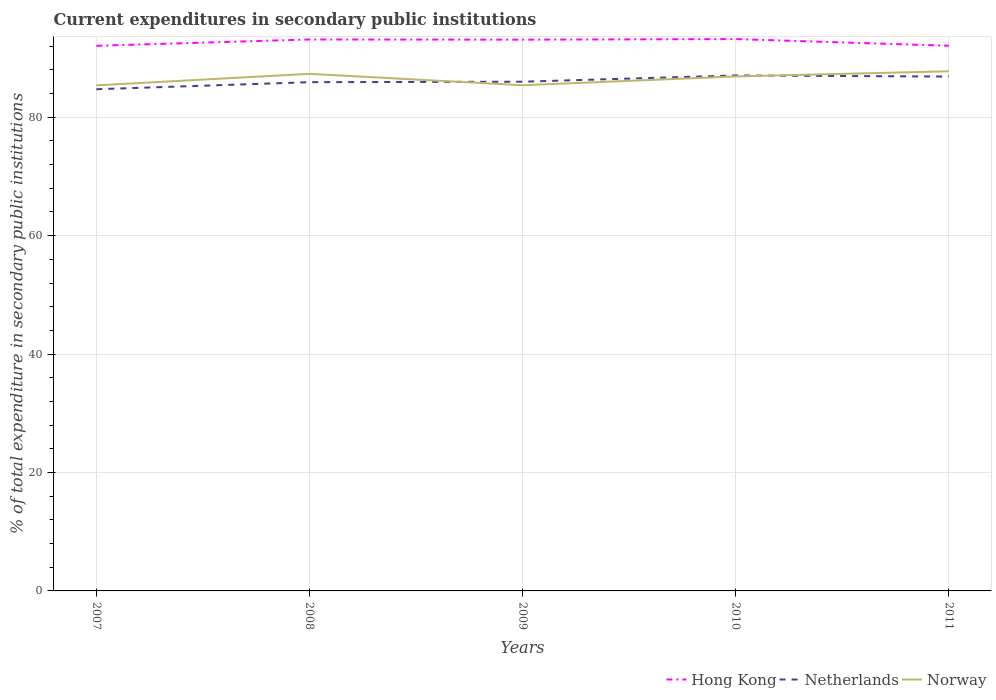Does the line corresponding to Hong Kong intersect with the line corresponding to Norway?
Your response must be concise. No. Is the number of lines equal to the number of legend labels?
Ensure brevity in your answer.  Yes. Across all years, what is the maximum current expenditures in secondary public institutions in Hong Kong?
Make the answer very short. 92.06. What is the total current expenditures in secondary public institutions in Norway in the graph?
Make the answer very short. -1.94. What is the difference between the highest and the second highest current expenditures in secondary public institutions in Netherlands?
Provide a short and direct response. 2.33. Is the current expenditures in secondary public institutions in Hong Kong strictly greater than the current expenditures in secondary public institutions in Norway over the years?
Make the answer very short. No. How many years are there in the graph?
Keep it short and to the point. 5. What is the difference between two consecutive major ticks on the Y-axis?
Give a very brief answer. 20. Are the values on the major ticks of Y-axis written in scientific E-notation?
Keep it short and to the point. No. Does the graph contain any zero values?
Make the answer very short. No. Does the graph contain grids?
Your answer should be very brief. Yes. How many legend labels are there?
Offer a very short reply. 3. What is the title of the graph?
Make the answer very short. Current expenditures in secondary public institutions. What is the label or title of the Y-axis?
Offer a terse response. % of total expenditure in secondary public institutions. What is the % of total expenditure in secondary public institutions of Hong Kong in 2007?
Provide a short and direct response. 92.06. What is the % of total expenditure in secondary public institutions of Netherlands in 2007?
Offer a very short reply. 84.72. What is the % of total expenditure in secondary public institutions in Norway in 2007?
Provide a short and direct response. 85.38. What is the % of total expenditure in secondary public institutions of Hong Kong in 2008?
Your answer should be compact. 93.13. What is the % of total expenditure in secondary public institutions of Netherlands in 2008?
Your answer should be compact. 85.92. What is the % of total expenditure in secondary public institutions in Norway in 2008?
Offer a terse response. 87.32. What is the % of total expenditure in secondary public institutions in Hong Kong in 2009?
Provide a succinct answer. 93.1. What is the % of total expenditure in secondary public institutions in Netherlands in 2009?
Provide a succinct answer. 86. What is the % of total expenditure in secondary public institutions of Norway in 2009?
Make the answer very short. 85.4. What is the % of total expenditure in secondary public institutions of Hong Kong in 2010?
Give a very brief answer. 93.19. What is the % of total expenditure in secondary public institutions in Netherlands in 2010?
Give a very brief answer. 87.05. What is the % of total expenditure in secondary public institutions of Norway in 2010?
Your answer should be compact. 86.89. What is the % of total expenditure in secondary public institutions in Hong Kong in 2011?
Offer a very short reply. 92.07. What is the % of total expenditure in secondary public institutions in Netherlands in 2011?
Ensure brevity in your answer.  86.86. What is the % of total expenditure in secondary public institutions of Norway in 2011?
Your response must be concise. 87.75. Across all years, what is the maximum % of total expenditure in secondary public institutions of Hong Kong?
Ensure brevity in your answer.  93.19. Across all years, what is the maximum % of total expenditure in secondary public institutions in Netherlands?
Keep it short and to the point. 87.05. Across all years, what is the maximum % of total expenditure in secondary public institutions of Norway?
Your answer should be compact. 87.75. Across all years, what is the minimum % of total expenditure in secondary public institutions of Hong Kong?
Keep it short and to the point. 92.06. Across all years, what is the minimum % of total expenditure in secondary public institutions in Netherlands?
Make the answer very short. 84.72. Across all years, what is the minimum % of total expenditure in secondary public institutions in Norway?
Ensure brevity in your answer.  85.38. What is the total % of total expenditure in secondary public institutions of Hong Kong in the graph?
Your response must be concise. 463.55. What is the total % of total expenditure in secondary public institutions in Netherlands in the graph?
Offer a terse response. 430.55. What is the total % of total expenditure in secondary public institutions of Norway in the graph?
Ensure brevity in your answer.  432.74. What is the difference between the % of total expenditure in secondary public institutions of Hong Kong in 2007 and that in 2008?
Your answer should be very brief. -1.07. What is the difference between the % of total expenditure in secondary public institutions of Netherlands in 2007 and that in 2008?
Your response must be concise. -1.19. What is the difference between the % of total expenditure in secondary public institutions in Norway in 2007 and that in 2008?
Your response must be concise. -1.94. What is the difference between the % of total expenditure in secondary public institutions in Hong Kong in 2007 and that in 2009?
Offer a terse response. -1.04. What is the difference between the % of total expenditure in secondary public institutions in Netherlands in 2007 and that in 2009?
Give a very brief answer. -1.27. What is the difference between the % of total expenditure in secondary public institutions of Norway in 2007 and that in 2009?
Provide a short and direct response. -0.02. What is the difference between the % of total expenditure in secondary public institutions in Hong Kong in 2007 and that in 2010?
Your answer should be very brief. -1.13. What is the difference between the % of total expenditure in secondary public institutions in Netherlands in 2007 and that in 2010?
Offer a very short reply. -2.33. What is the difference between the % of total expenditure in secondary public institutions in Norway in 2007 and that in 2010?
Give a very brief answer. -1.51. What is the difference between the % of total expenditure in secondary public institutions of Hong Kong in 2007 and that in 2011?
Make the answer very short. -0.01. What is the difference between the % of total expenditure in secondary public institutions in Netherlands in 2007 and that in 2011?
Give a very brief answer. -2.14. What is the difference between the % of total expenditure in secondary public institutions of Norway in 2007 and that in 2011?
Provide a succinct answer. -2.37. What is the difference between the % of total expenditure in secondary public institutions in Hong Kong in 2008 and that in 2009?
Your answer should be compact. 0.03. What is the difference between the % of total expenditure in secondary public institutions in Netherlands in 2008 and that in 2009?
Ensure brevity in your answer.  -0.08. What is the difference between the % of total expenditure in secondary public institutions of Norway in 2008 and that in 2009?
Your response must be concise. 1.92. What is the difference between the % of total expenditure in secondary public institutions of Hong Kong in 2008 and that in 2010?
Your answer should be compact. -0.07. What is the difference between the % of total expenditure in secondary public institutions of Netherlands in 2008 and that in 2010?
Your response must be concise. -1.14. What is the difference between the % of total expenditure in secondary public institutions of Norway in 2008 and that in 2010?
Provide a short and direct response. 0.44. What is the difference between the % of total expenditure in secondary public institutions in Hong Kong in 2008 and that in 2011?
Keep it short and to the point. 1.06. What is the difference between the % of total expenditure in secondary public institutions in Netherlands in 2008 and that in 2011?
Your answer should be compact. -0.95. What is the difference between the % of total expenditure in secondary public institutions of Norway in 2008 and that in 2011?
Provide a succinct answer. -0.43. What is the difference between the % of total expenditure in secondary public institutions in Hong Kong in 2009 and that in 2010?
Offer a very short reply. -0.1. What is the difference between the % of total expenditure in secondary public institutions of Netherlands in 2009 and that in 2010?
Your answer should be very brief. -1.06. What is the difference between the % of total expenditure in secondary public institutions in Norway in 2009 and that in 2010?
Provide a succinct answer. -1.49. What is the difference between the % of total expenditure in secondary public institutions in Hong Kong in 2009 and that in 2011?
Give a very brief answer. 1.03. What is the difference between the % of total expenditure in secondary public institutions in Netherlands in 2009 and that in 2011?
Provide a short and direct response. -0.87. What is the difference between the % of total expenditure in secondary public institutions in Norway in 2009 and that in 2011?
Your response must be concise. -2.35. What is the difference between the % of total expenditure in secondary public institutions in Hong Kong in 2010 and that in 2011?
Provide a short and direct response. 1.13. What is the difference between the % of total expenditure in secondary public institutions in Netherlands in 2010 and that in 2011?
Ensure brevity in your answer.  0.19. What is the difference between the % of total expenditure in secondary public institutions of Norway in 2010 and that in 2011?
Provide a succinct answer. -0.87. What is the difference between the % of total expenditure in secondary public institutions of Hong Kong in 2007 and the % of total expenditure in secondary public institutions of Netherlands in 2008?
Provide a short and direct response. 6.15. What is the difference between the % of total expenditure in secondary public institutions of Hong Kong in 2007 and the % of total expenditure in secondary public institutions of Norway in 2008?
Make the answer very short. 4.74. What is the difference between the % of total expenditure in secondary public institutions in Netherlands in 2007 and the % of total expenditure in secondary public institutions in Norway in 2008?
Ensure brevity in your answer.  -2.6. What is the difference between the % of total expenditure in secondary public institutions in Hong Kong in 2007 and the % of total expenditure in secondary public institutions in Netherlands in 2009?
Make the answer very short. 6.07. What is the difference between the % of total expenditure in secondary public institutions in Hong Kong in 2007 and the % of total expenditure in secondary public institutions in Norway in 2009?
Your answer should be very brief. 6.66. What is the difference between the % of total expenditure in secondary public institutions in Netherlands in 2007 and the % of total expenditure in secondary public institutions in Norway in 2009?
Keep it short and to the point. -0.68. What is the difference between the % of total expenditure in secondary public institutions of Hong Kong in 2007 and the % of total expenditure in secondary public institutions of Netherlands in 2010?
Your answer should be very brief. 5.01. What is the difference between the % of total expenditure in secondary public institutions of Hong Kong in 2007 and the % of total expenditure in secondary public institutions of Norway in 2010?
Ensure brevity in your answer.  5.17. What is the difference between the % of total expenditure in secondary public institutions in Netherlands in 2007 and the % of total expenditure in secondary public institutions in Norway in 2010?
Provide a short and direct response. -2.16. What is the difference between the % of total expenditure in secondary public institutions of Hong Kong in 2007 and the % of total expenditure in secondary public institutions of Netherlands in 2011?
Make the answer very short. 5.2. What is the difference between the % of total expenditure in secondary public institutions in Hong Kong in 2007 and the % of total expenditure in secondary public institutions in Norway in 2011?
Your response must be concise. 4.31. What is the difference between the % of total expenditure in secondary public institutions of Netherlands in 2007 and the % of total expenditure in secondary public institutions of Norway in 2011?
Give a very brief answer. -3.03. What is the difference between the % of total expenditure in secondary public institutions of Hong Kong in 2008 and the % of total expenditure in secondary public institutions of Netherlands in 2009?
Ensure brevity in your answer.  7.13. What is the difference between the % of total expenditure in secondary public institutions of Hong Kong in 2008 and the % of total expenditure in secondary public institutions of Norway in 2009?
Ensure brevity in your answer.  7.73. What is the difference between the % of total expenditure in secondary public institutions of Netherlands in 2008 and the % of total expenditure in secondary public institutions of Norway in 2009?
Give a very brief answer. 0.52. What is the difference between the % of total expenditure in secondary public institutions in Hong Kong in 2008 and the % of total expenditure in secondary public institutions in Netherlands in 2010?
Your response must be concise. 6.08. What is the difference between the % of total expenditure in secondary public institutions of Hong Kong in 2008 and the % of total expenditure in secondary public institutions of Norway in 2010?
Offer a very short reply. 6.24. What is the difference between the % of total expenditure in secondary public institutions of Netherlands in 2008 and the % of total expenditure in secondary public institutions of Norway in 2010?
Your answer should be very brief. -0.97. What is the difference between the % of total expenditure in secondary public institutions in Hong Kong in 2008 and the % of total expenditure in secondary public institutions in Netherlands in 2011?
Your answer should be very brief. 6.27. What is the difference between the % of total expenditure in secondary public institutions of Hong Kong in 2008 and the % of total expenditure in secondary public institutions of Norway in 2011?
Offer a very short reply. 5.37. What is the difference between the % of total expenditure in secondary public institutions in Netherlands in 2008 and the % of total expenditure in secondary public institutions in Norway in 2011?
Your answer should be very brief. -1.84. What is the difference between the % of total expenditure in secondary public institutions of Hong Kong in 2009 and the % of total expenditure in secondary public institutions of Netherlands in 2010?
Offer a terse response. 6.05. What is the difference between the % of total expenditure in secondary public institutions in Hong Kong in 2009 and the % of total expenditure in secondary public institutions in Norway in 2010?
Make the answer very short. 6.21. What is the difference between the % of total expenditure in secondary public institutions of Netherlands in 2009 and the % of total expenditure in secondary public institutions of Norway in 2010?
Provide a short and direct response. -0.89. What is the difference between the % of total expenditure in secondary public institutions in Hong Kong in 2009 and the % of total expenditure in secondary public institutions in Netherlands in 2011?
Offer a very short reply. 6.24. What is the difference between the % of total expenditure in secondary public institutions of Hong Kong in 2009 and the % of total expenditure in secondary public institutions of Norway in 2011?
Offer a terse response. 5.34. What is the difference between the % of total expenditure in secondary public institutions in Netherlands in 2009 and the % of total expenditure in secondary public institutions in Norway in 2011?
Offer a very short reply. -1.76. What is the difference between the % of total expenditure in secondary public institutions in Hong Kong in 2010 and the % of total expenditure in secondary public institutions in Netherlands in 2011?
Keep it short and to the point. 6.33. What is the difference between the % of total expenditure in secondary public institutions of Hong Kong in 2010 and the % of total expenditure in secondary public institutions of Norway in 2011?
Keep it short and to the point. 5.44. What is the difference between the % of total expenditure in secondary public institutions of Netherlands in 2010 and the % of total expenditure in secondary public institutions of Norway in 2011?
Your answer should be very brief. -0.7. What is the average % of total expenditure in secondary public institutions of Hong Kong per year?
Your answer should be compact. 92.71. What is the average % of total expenditure in secondary public institutions in Netherlands per year?
Provide a succinct answer. 86.11. What is the average % of total expenditure in secondary public institutions of Norway per year?
Offer a terse response. 86.55. In the year 2007, what is the difference between the % of total expenditure in secondary public institutions in Hong Kong and % of total expenditure in secondary public institutions in Netherlands?
Your answer should be very brief. 7.34. In the year 2007, what is the difference between the % of total expenditure in secondary public institutions of Hong Kong and % of total expenditure in secondary public institutions of Norway?
Offer a very short reply. 6.68. In the year 2007, what is the difference between the % of total expenditure in secondary public institutions of Netherlands and % of total expenditure in secondary public institutions of Norway?
Provide a short and direct response. -0.66. In the year 2008, what is the difference between the % of total expenditure in secondary public institutions of Hong Kong and % of total expenditure in secondary public institutions of Netherlands?
Provide a succinct answer. 7.21. In the year 2008, what is the difference between the % of total expenditure in secondary public institutions in Hong Kong and % of total expenditure in secondary public institutions in Norway?
Provide a succinct answer. 5.8. In the year 2008, what is the difference between the % of total expenditure in secondary public institutions of Netherlands and % of total expenditure in secondary public institutions of Norway?
Ensure brevity in your answer.  -1.41. In the year 2009, what is the difference between the % of total expenditure in secondary public institutions of Hong Kong and % of total expenditure in secondary public institutions of Netherlands?
Offer a very short reply. 7.1. In the year 2009, what is the difference between the % of total expenditure in secondary public institutions in Hong Kong and % of total expenditure in secondary public institutions in Norway?
Offer a very short reply. 7.7. In the year 2009, what is the difference between the % of total expenditure in secondary public institutions of Netherlands and % of total expenditure in secondary public institutions of Norway?
Ensure brevity in your answer.  0.6. In the year 2010, what is the difference between the % of total expenditure in secondary public institutions in Hong Kong and % of total expenditure in secondary public institutions in Netherlands?
Offer a very short reply. 6.14. In the year 2010, what is the difference between the % of total expenditure in secondary public institutions in Hong Kong and % of total expenditure in secondary public institutions in Norway?
Your answer should be compact. 6.31. In the year 2010, what is the difference between the % of total expenditure in secondary public institutions in Netherlands and % of total expenditure in secondary public institutions in Norway?
Provide a succinct answer. 0.16. In the year 2011, what is the difference between the % of total expenditure in secondary public institutions in Hong Kong and % of total expenditure in secondary public institutions in Netherlands?
Provide a short and direct response. 5.2. In the year 2011, what is the difference between the % of total expenditure in secondary public institutions of Hong Kong and % of total expenditure in secondary public institutions of Norway?
Your answer should be very brief. 4.31. In the year 2011, what is the difference between the % of total expenditure in secondary public institutions of Netherlands and % of total expenditure in secondary public institutions of Norway?
Ensure brevity in your answer.  -0.89. What is the ratio of the % of total expenditure in secondary public institutions in Hong Kong in 2007 to that in 2008?
Provide a short and direct response. 0.99. What is the ratio of the % of total expenditure in secondary public institutions in Netherlands in 2007 to that in 2008?
Provide a short and direct response. 0.99. What is the ratio of the % of total expenditure in secondary public institutions in Norway in 2007 to that in 2008?
Ensure brevity in your answer.  0.98. What is the ratio of the % of total expenditure in secondary public institutions in Hong Kong in 2007 to that in 2009?
Keep it short and to the point. 0.99. What is the ratio of the % of total expenditure in secondary public institutions of Netherlands in 2007 to that in 2009?
Provide a short and direct response. 0.99. What is the ratio of the % of total expenditure in secondary public institutions of Hong Kong in 2007 to that in 2010?
Provide a short and direct response. 0.99. What is the ratio of the % of total expenditure in secondary public institutions of Netherlands in 2007 to that in 2010?
Provide a short and direct response. 0.97. What is the ratio of the % of total expenditure in secondary public institutions in Norway in 2007 to that in 2010?
Make the answer very short. 0.98. What is the ratio of the % of total expenditure in secondary public institutions of Netherlands in 2007 to that in 2011?
Offer a terse response. 0.98. What is the ratio of the % of total expenditure in secondary public institutions of Norway in 2007 to that in 2011?
Keep it short and to the point. 0.97. What is the ratio of the % of total expenditure in secondary public institutions of Hong Kong in 2008 to that in 2009?
Ensure brevity in your answer.  1. What is the ratio of the % of total expenditure in secondary public institutions in Norway in 2008 to that in 2009?
Provide a short and direct response. 1.02. What is the ratio of the % of total expenditure in secondary public institutions of Norway in 2008 to that in 2010?
Your response must be concise. 1. What is the ratio of the % of total expenditure in secondary public institutions of Hong Kong in 2008 to that in 2011?
Your answer should be very brief. 1.01. What is the ratio of the % of total expenditure in secondary public institutions in Norway in 2008 to that in 2011?
Ensure brevity in your answer.  1. What is the ratio of the % of total expenditure in secondary public institutions in Hong Kong in 2009 to that in 2010?
Provide a short and direct response. 1. What is the ratio of the % of total expenditure in secondary public institutions of Netherlands in 2009 to that in 2010?
Offer a very short reply. 0.99. What is the ratio of the % of total expenditure in secondary public institutions in Norway in 2009 to that in 2010?
Make the answer very short. 0.98. What is the ratio of the % of total expenditure in secondary public institutions of Hong Kong in 2009 to that in 2011?
Your response must be concise. 1.01. What is the ratio of the % of total expenditure in secondary public institutions of Norway in 2009 to that in 2011?
Provide a short and direct response. 0.97. What is the ratio of the % of total expenditure in secondary public institutions in Hong Kong in 2010 to that in 2011?
Offer a terse response. 1.01. What is the ratio of the % of total expenditure in secondary public institutions in Norway in 2010 to that in 2011?
Your answer should be compact. 0.99. What is the difference between the highest and the second highest % of total expenditure in secondary public institutions of Hong Kong?
Provide a short and direct response. 0.07. What is the difference between the highest and the second highest % of total expenditure in secondary public institutions in Netherlands?
Offer a terse response. 0.19. What is the difference between the highest and the second highest % of total expenditure in secondary public institutions of Norway?
Ensure brevity in your answer.  0.43. What is the difference between the highest and the lowest % of total expenditure in secondary public institutions in Hong Kong?
Offer a very short reply. 1.13. What is the difference between the highest and the lowest % of total expenditure in secondary public institutions of Netherlands?
Offer a terse response. 2.33. What is the difference between the highest and the lowest % of total expenditure in secondary public institutions of Norway?
Keep it short and to the point. 2.37. 